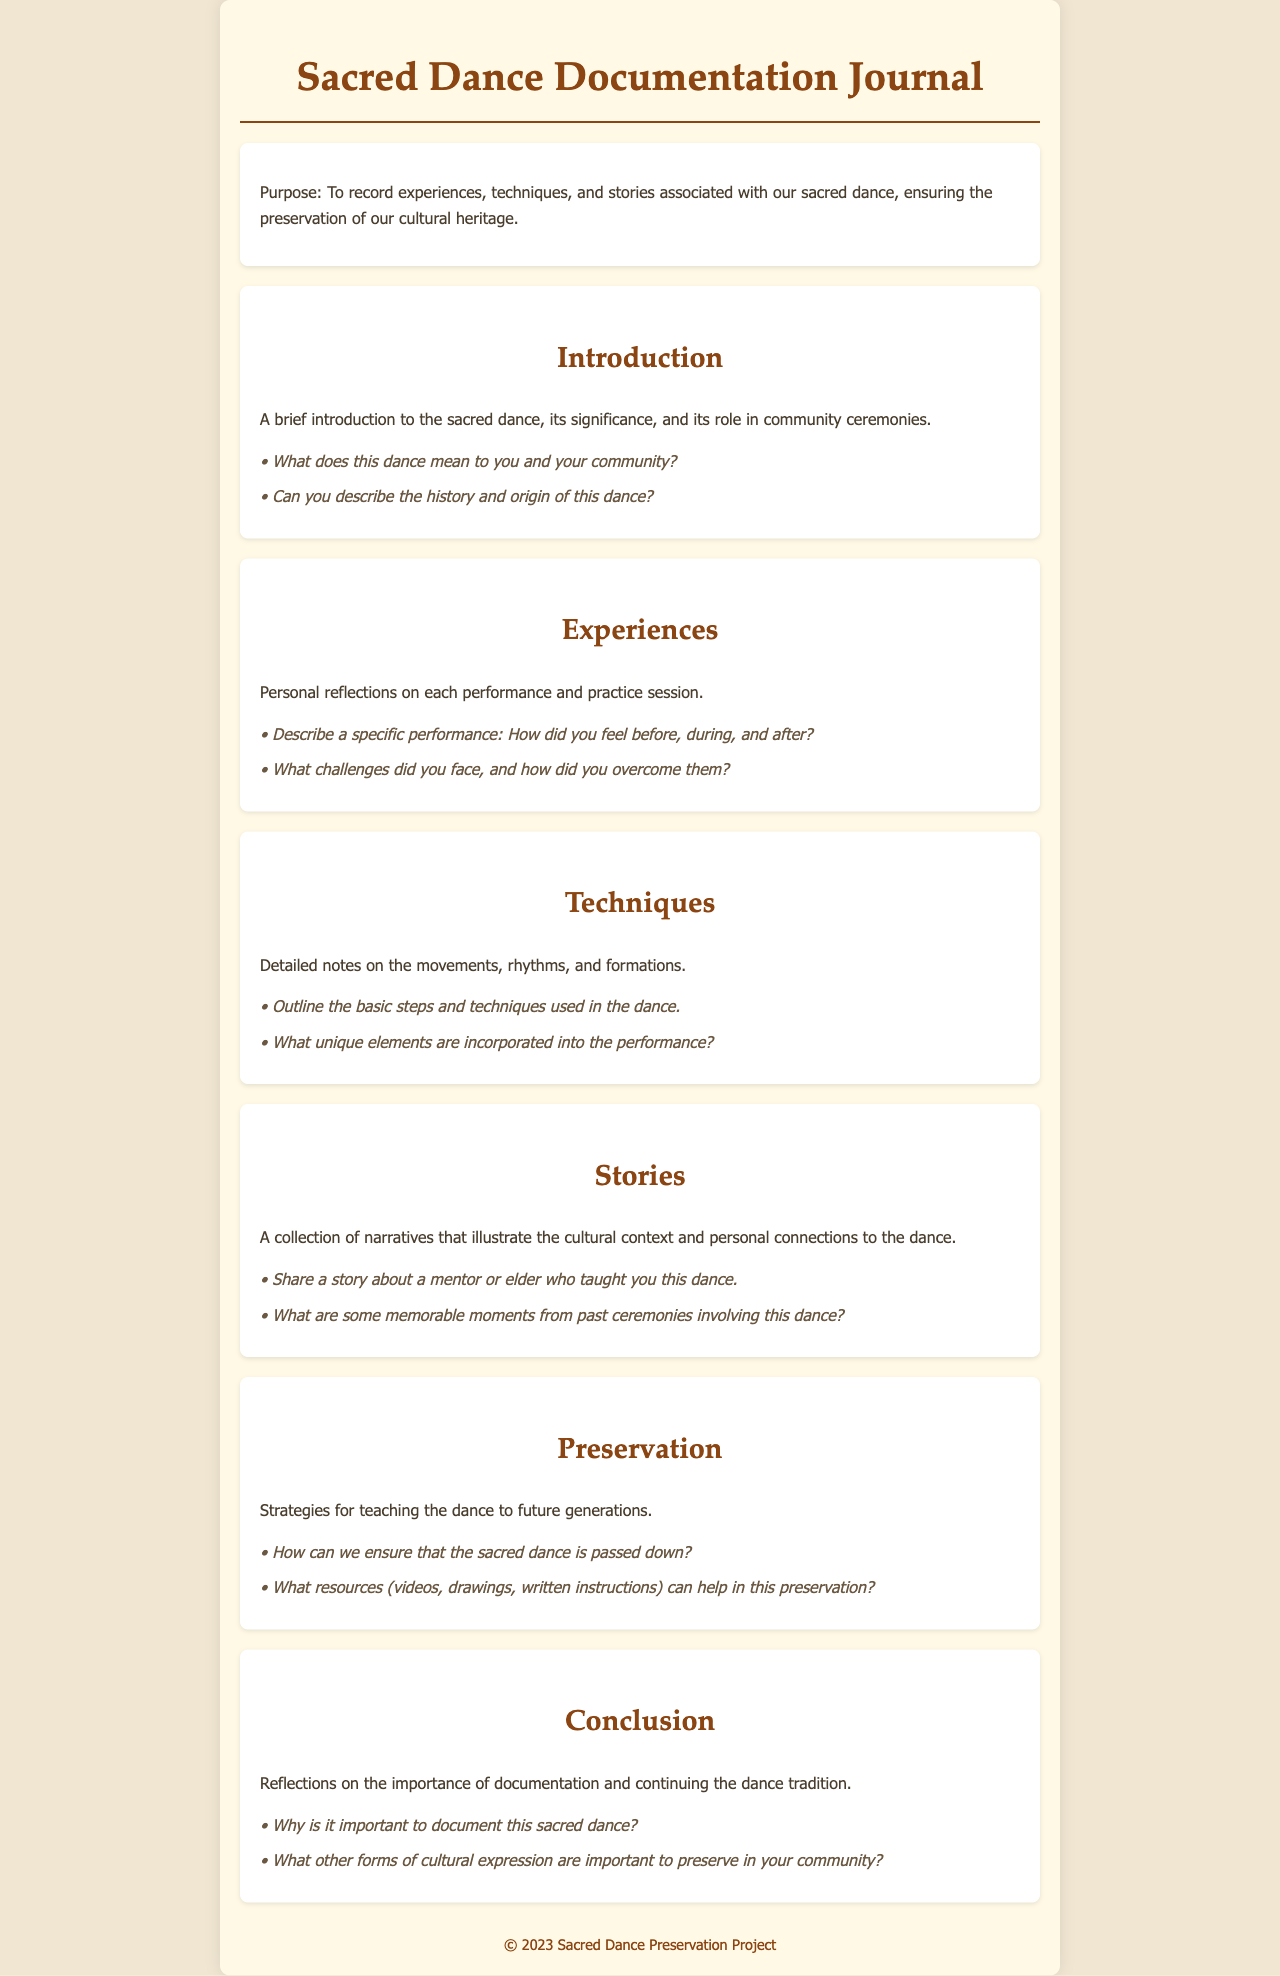What is the purpose of the Sacred Dance Documentation Journal? The purpose is to record experiences, techniques, and stories associated with the sacred dance, ensuring the preservation of our cultural heritage.
Answer: To record experiences, techniques, and stories What section comes after "Introduction"? The sections are organized sequentially, and after "Introduction," the next section is "Experiences."
Answer: Experiences What is one prompt from the "Techniques" section? Each section contains prompts designed for response; one from "Techniques" focuses on outlining basic steps and techniques.
Answer: Outline the basic steps and techniques used in the dance How are personal reflections categorized in the journal? Personal reflections are categorized under the section titled "Experiences."
Answer: Experiences What is the main focus of the "Preservation" section? This section outlines strategies for teaching the dance to future generations.
Answer: Strategies for teaching the dance Why is documentation considered important? The conclusion reflects on the importance of documentation for continuing the dance tradition.
Answer: To continue the dance tradition Share a story about a mentor or elder. This is a prompt found in the "Stories" section, encouraging sharing narratives related to the dance.
Answer: Share a story about a mentor or elder who taught you this dance 